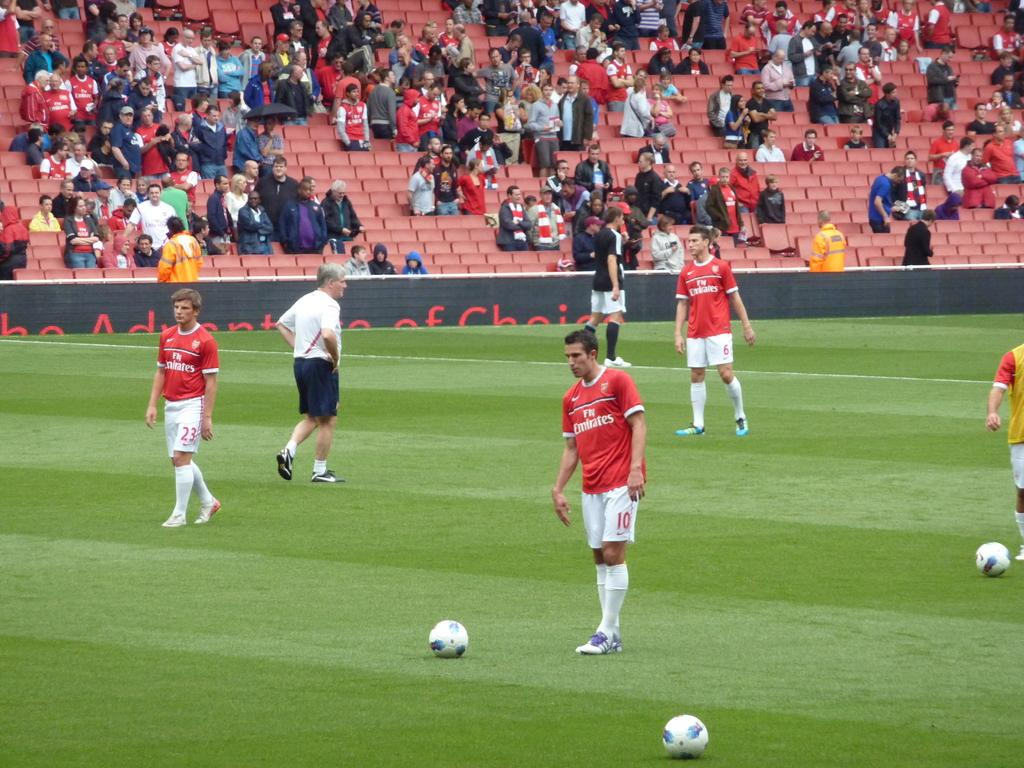<image>
Share a concise interpretation of the image provided. a few players with one that says fly emirates on it 